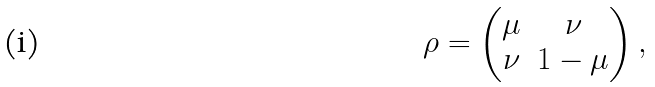<formula> <loc_0><loc_0><loc_500><loc_500>\rho = \begin{pmatrix} \mu & \nu \\ \nu & 1 - \mu \end{pmatrix} ,</formula> 